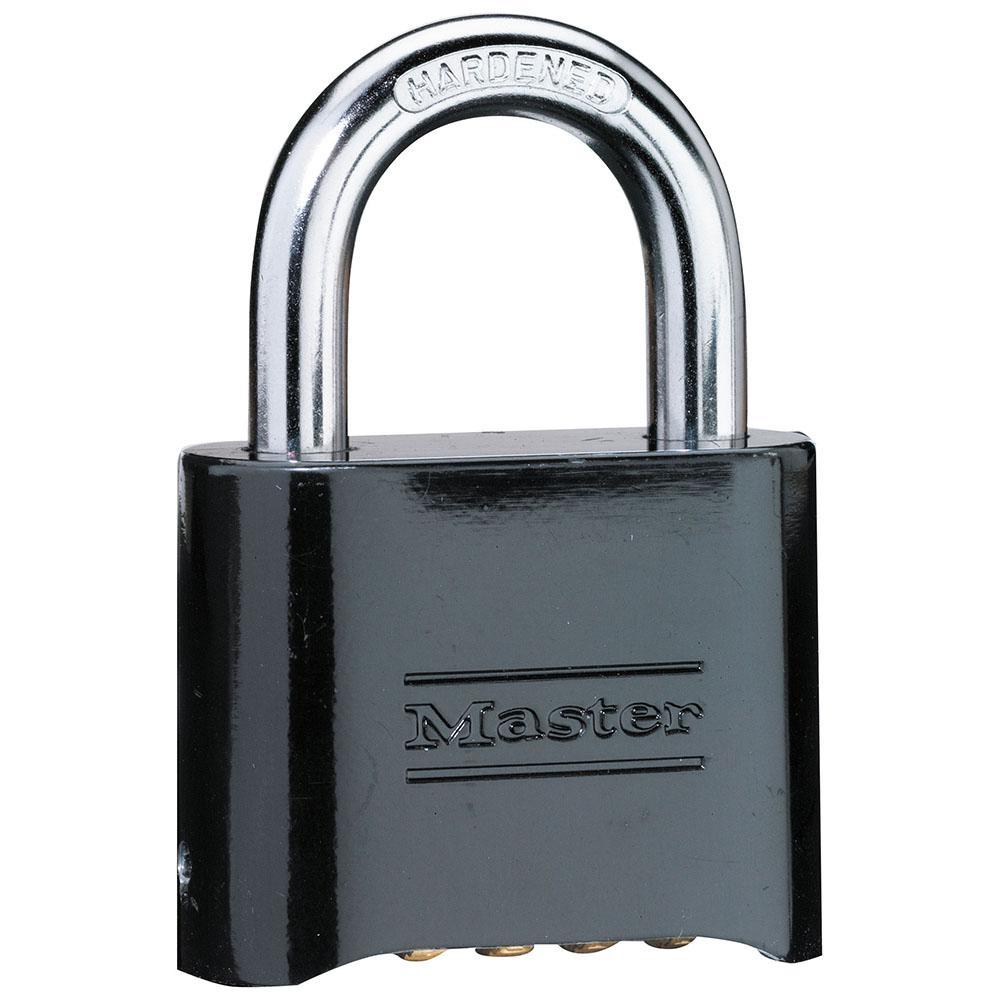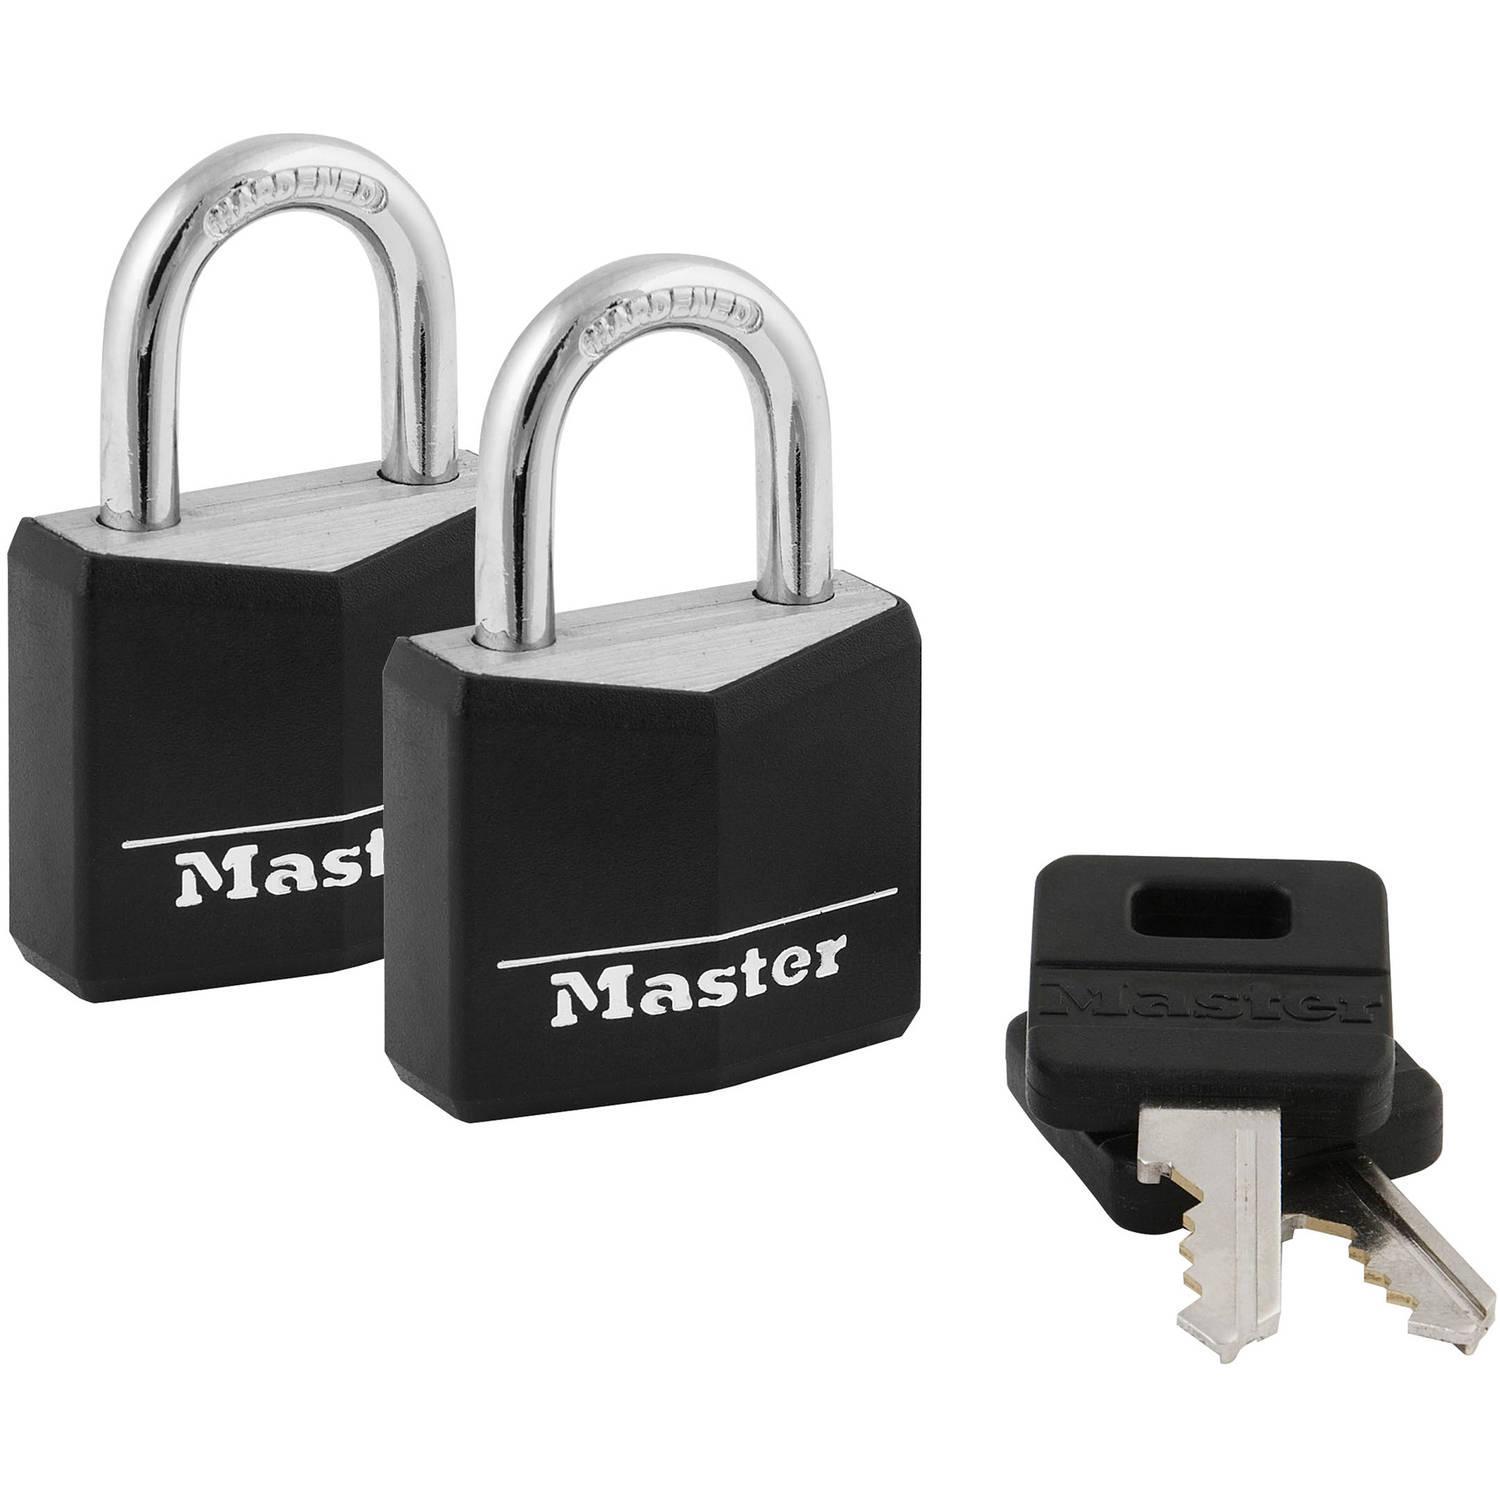The first image is the image on the left, the second image is the image on the right. For the images shown, is this caption "All locks are combination locks, with the number belts visible in the images." true? Answer yes or no. No. The first image is the image on the left, the second image is the image on the right. Considering the images on both sides, is "There are no less than two black padlocks" valid? Answer yes or no. Yes. 